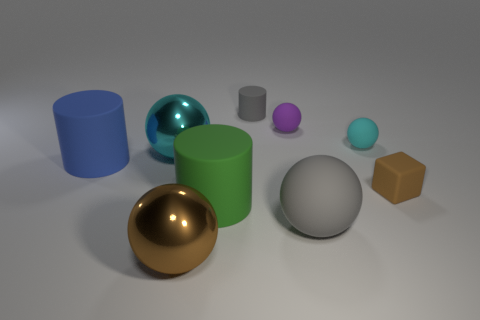What can you tell me about the colors of the objects? The objects feature a range of colors: one object each in blue, green, purple, and brown, along with two distinct shades of gray for the spheres and a teal for the small cylinder. The colors contribute to a harmonious but diverse color palette. 